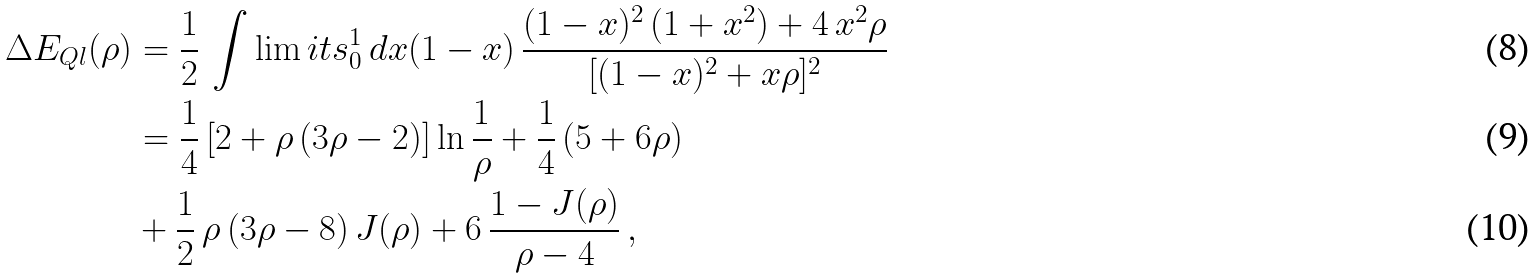<formula> <loc_0><loc_0><loc_500><loc_500>\Delta E _ { Q l } ( \rho ) & = \frac { 1 } { 2 } \, \int \lim i t s _ { 0 } ^ { 1 } \, d x ( 1 - x ) \, \frac { ( 1 - x ) ^ { 2 } \, ( 1 + x ^ { 2 } ) + 4 \, x ^ { 2 } \rho } { [ ( 1 - x ) ^ { 2 } + x \rho ] ^ { 2 } } \\ & = \frac { 1 } { 4 } \, [ 2 + \rho \, ( 3 \rho - 2 ) ] \ln \frac { 1 } { \rho } + \frac { 1 } { 4 } \, ( 5 + 6 \rho ) \\ & + \frac { 1 } { 2 } \, \rho \, ( 3 \rho - 8 ) \, J ( \rho ) + 6 \, \frac { 1 - J ( \rho ) } { \rho - 4 } \, ,</formula> 